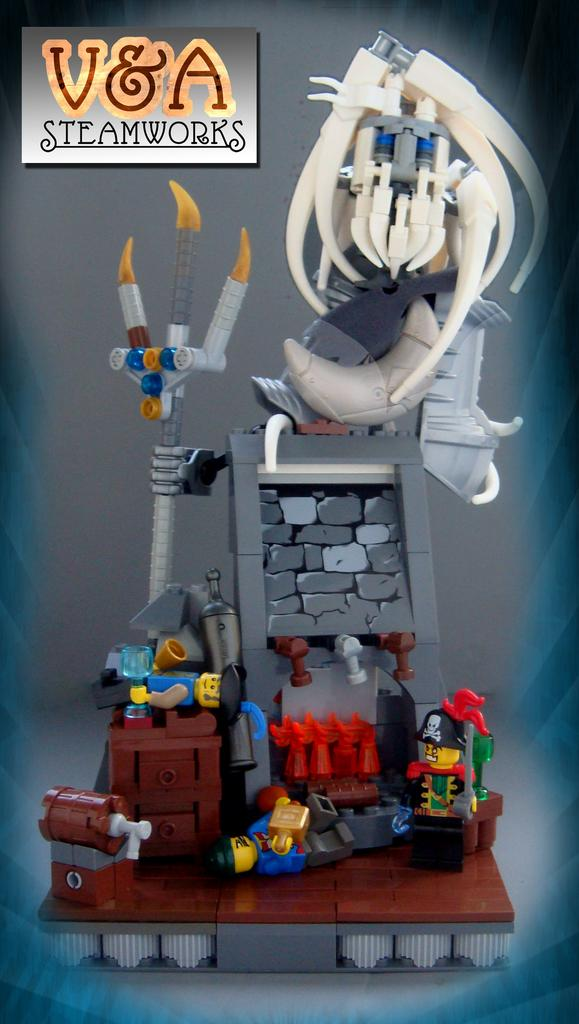What type of images are present in the image? The image contains animated images. What kind of weapon can be seen in the image? There is a weapon in the image. What material is present in the image? There are bricks in the image. Are there any other objects in the image besides the weapon and bricks? Yes, there are other objects in the image. Where is the text located in the image? The text is in the bottom left corner of the image. What type of meat is being cooked on the grill in the image? There is no grill or meat present in the image. 